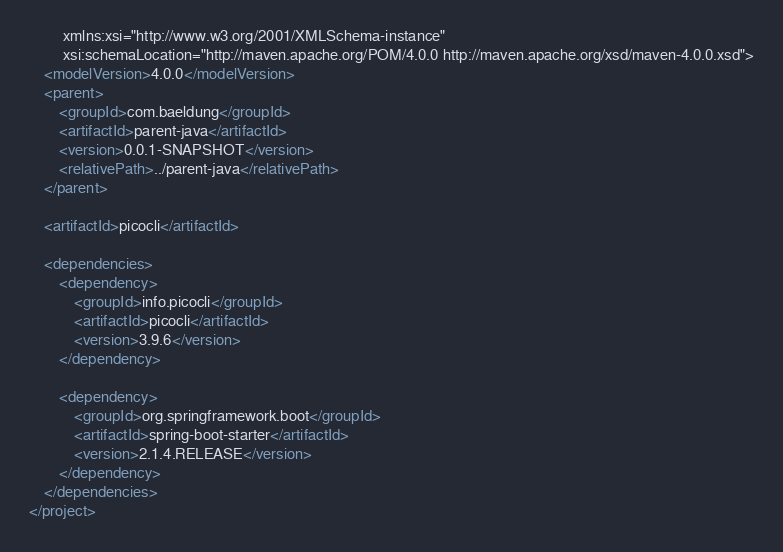Convert code to text. <code><loc_0><loc_0><loc_500><loc_500><_XML_>         xmlns:xsi="http://www.w3.org/2001/XMLSchema-instance"
         xsi:schemaLocation="http://maven.apache.org/POM/4.0.0 http://maven.apache.org/xsd/maven-4.0.0.xsd">
    <modelVersion>4.0.0</modelVersion>
    <parent>
        <groupId>com.baeldung</groupId>
        <artifactId>parent-java</artifactId>
        <version>0.0.1-SNAPSHOT</version>
        <relativePath>../parent-java</relativePath>
    </parent>

    <artifactId>picocli</artifactId>

    <dependencies>
        <dependency>
            <groupId>info.picocli</groupId>
            <artifactId>picocli</artifactId>
            <version>3.9.6</version>
        </dependency>

        <dependency>
            <groupId>org.springframework.boot</groupId>
            <artifactId>spring-boot-starter</artifactId>
            <version>2.1.4.RELEASE</version>
        </dependency>
    </dependencies>
</project></code> 